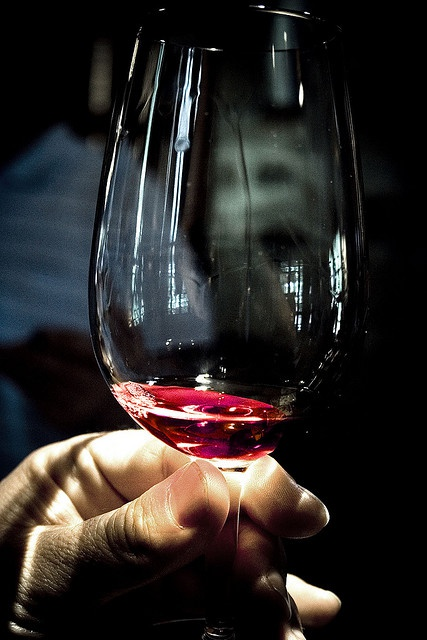Describe the objects in this image and their specific colors. I can see wine glass in black, gray, purple, and white tones and people in black, ivory, and maroon tones in this image. 